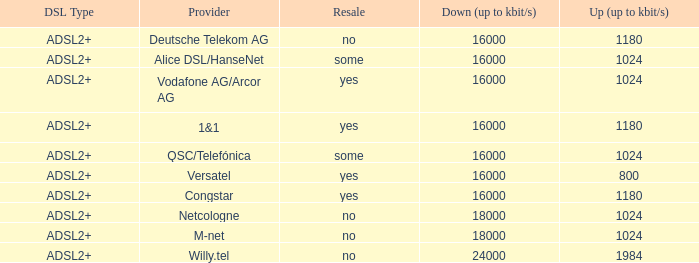How many vendors exist where the resale category is yes and bandwidth is up is 1024? 1.0. 